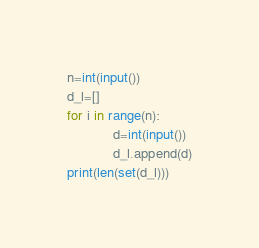<code> <loc_0><loc_0><loc_500><loc_500><_Python_>n=int(input())
d_l=[]
for i in range(n):
            d=int(input())
            d_l.append(d)
print(len(set(d_l)))

</code> 